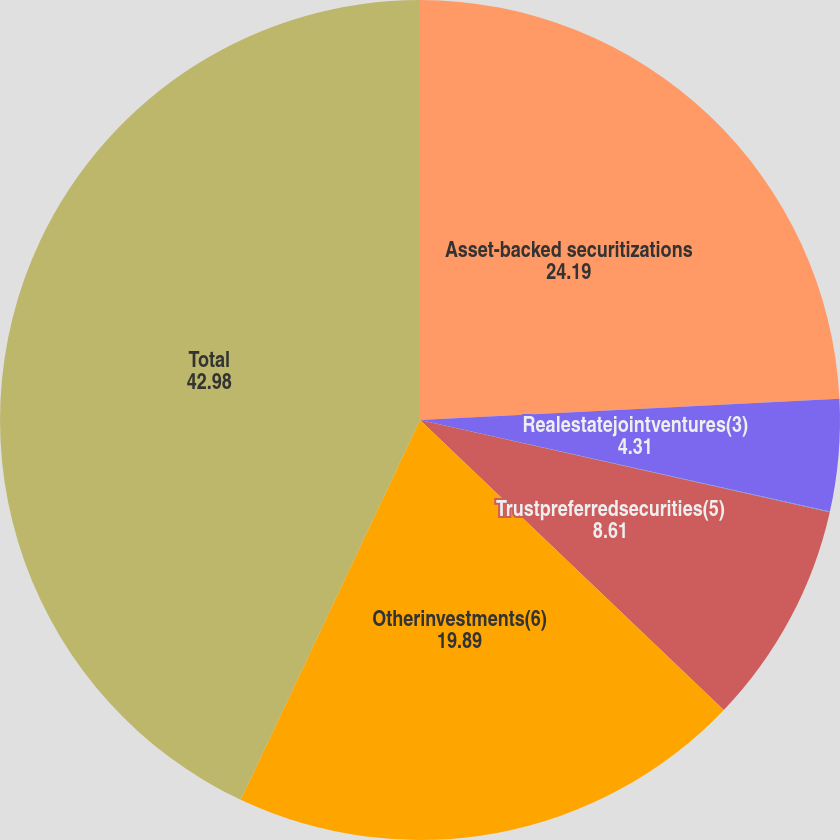<chart> <loc_0><loc_0><loc_500><loc_500><pie_chart><fcel>Asset-backed securitizations<fcel>Realestatejointventures(3)<fcel>Unnamed: 2<fcel>Trustpreferredsecurities(5)<fcel>Otherinvestments(6)<fcel>Total<nl><fcel>24.19%<fcel>4.31%<fcel>0.02%<fcel>8.61%<fcel>19.89%<fcel>42.98%<nl></chart> 